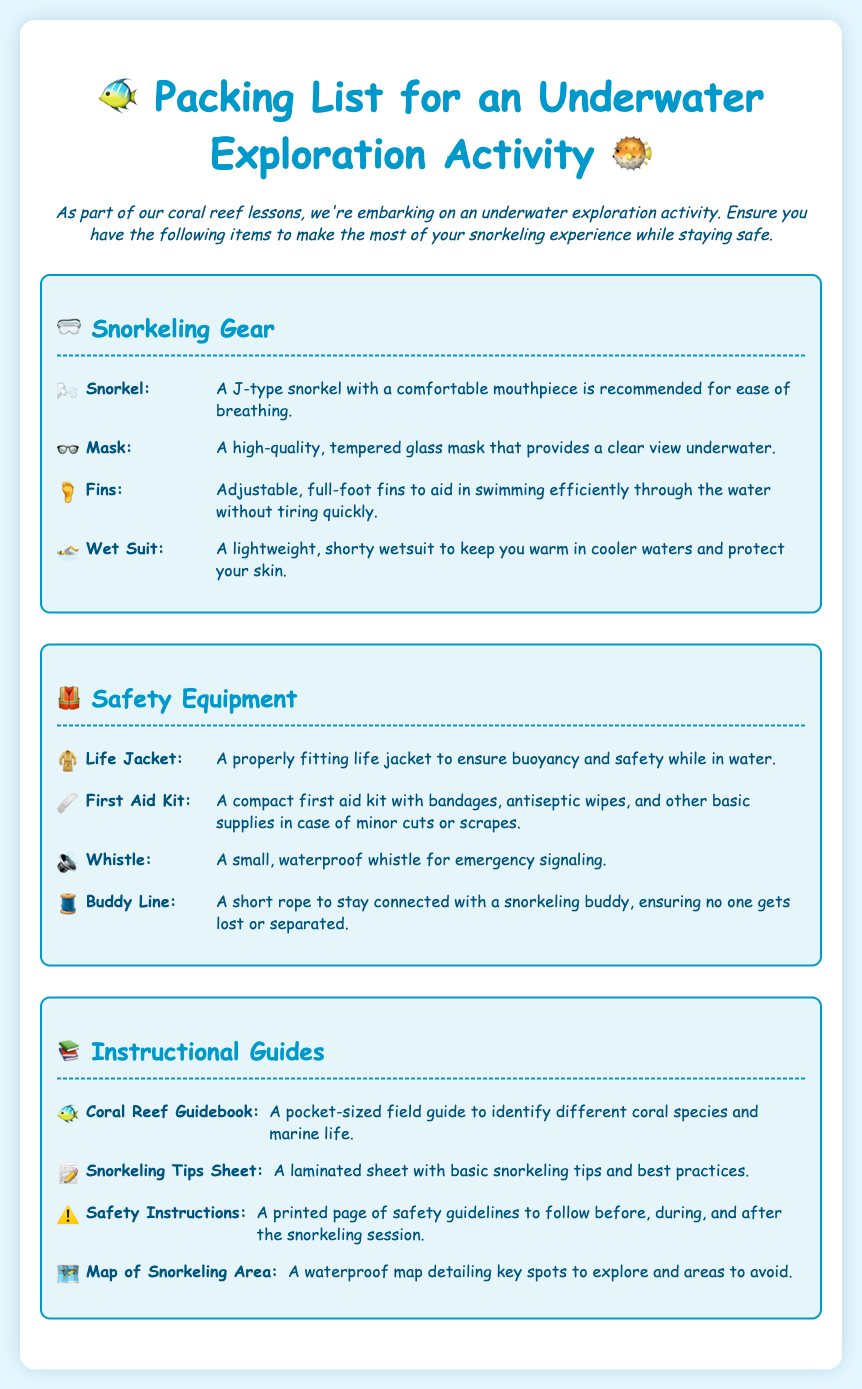what is the title of the document? The title of the document is given clearly at the top, which is "Packing List for an Underwater Exploration Activity."
Answer: Packing List for an Underwater Exploration Activity how many items are listed under Snorkeling Gear? The number of items in the Snorkeling Gear section can be counted in the list provided, which includes four distinct items.
Answer: 4 what type of wetsuit is recommended? The document describes the wetsuit recommended as "a lightweight, shorty wetsuit."
Answer: lightweight, shorty wetsuit what item is used for emergency signaling? The document states that a whistle is intended for emergency signaling.
Answer: whistle what should you check before snorkeling according to the safety section? The safety section includes essential items to ensure safety, notably the life jacket.
Answer: life jacket how many items are listed in the Safety Equipment section? The count of items in the Safety Equipment section can be established, which totals four.
Answer: 4 what is the purpose of the Buddy Line? The purpose of the Buddy Line is clearly described as a means to stay connected with a snorkeling buddy.
Answer: to stay connected what is included in the Instructional Guides section? The Instructional Guides section comprises various guides and sheets related to snorkeling and coral reef education.
Answer: Coral Reef Guidebook, Snorkeling Tips Sheet, Safety Instructions, Map of Snorkeling Area what color is the background of the document? The color scheme of the document is specified in the style, indicating a light blue background.
Answer: #e6f7ff 